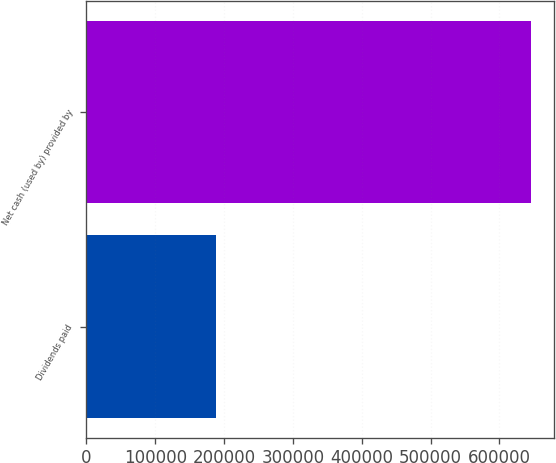<chart> <loc_0><loc_0><loc_500><loc_500><bar_chart><fcel>Dividends paid<fcel>Net cash (used by) provided by<nl><fcel>187688<fcel>646457<nl></chart> 